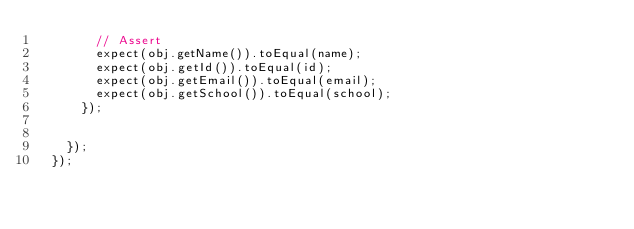<code> <loc_0><loc_0><loc_500><loc_500><_JavaScript_>        // Assert
        expect(obj.getName()).toEqual(name);
        expect(obj.getId()).toEqual(id);
        expect(obj.getEmail()).toEqual(email);
        expect(obj.getSchool()).toEqual(school);
      });
  
    
    });
  });
  </code> 